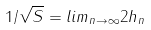Convert formula to latex. <formula><loc_0><loc_0><loc_500><loc_500>1 / \sqrt { S } = l i m _ { n \rightarrow \infty } 2 h _ { n }</formula> 